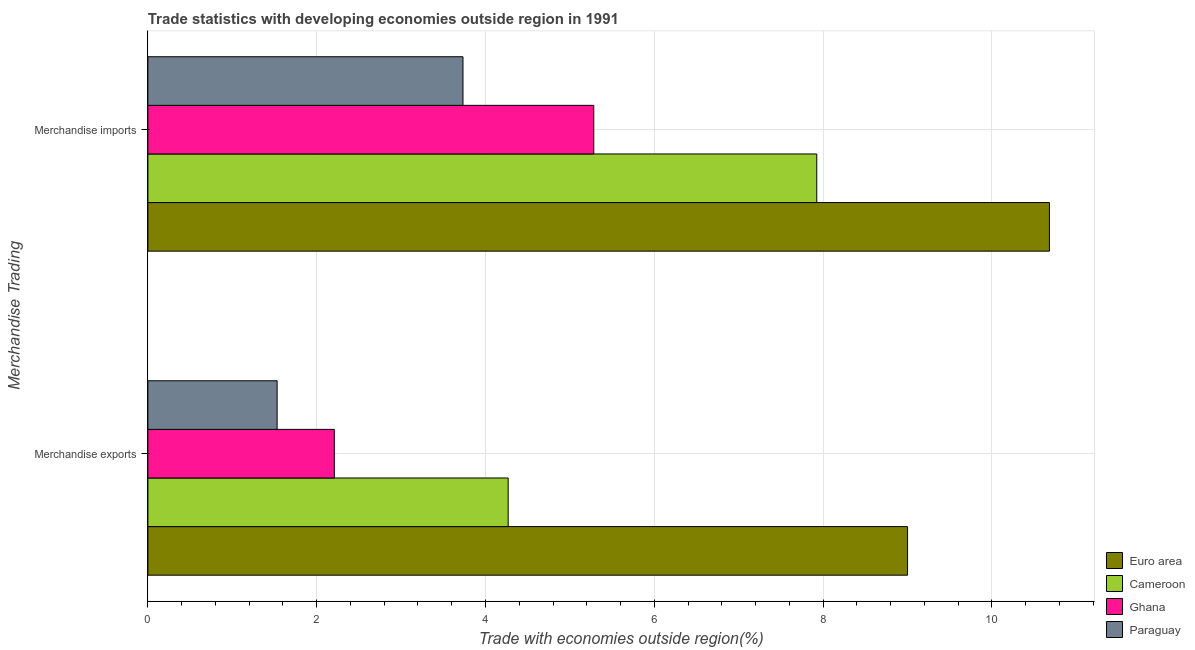How many different coloured bars are there?
Your response must be concise. 4. Are the number of bars on each tick of the Y-axis equal?
Keep it short and to the point. Yes. How many bars are there on the 2nd tick from the bottom?
Provide a succinct answer. 4. What is the merchandise exports in Ghana?
Offer a very short reply. 2.21. Across all countries, what is the maximum merchandise imports?
Ensure brevity in your answer.  10.68. Across all countries, what is the minimum merchandise imports?
Your answer should be compact. 3.73. In which country was the merchandise exports maximum?
Offer a terse response. Euro area. In which country was the merchandise exports minimum?
Provide a short and direct response. Paraguay. What is the total merchandise exports in the graph?
Make the answer very short. 17.01. What is the difference between the merchandise imports in Euro area and that in Paraguay?
Offer a terse response. 6.95. What is the difference between the merchandise exports in Euro area and the merchandise imports in Paraguay?
Keep it short and to the point. 5.27. What is the average merchandise exports per country?
Provide a succinct answer. 4.25. What is the difference between the merchandise exports and merchandise imports in Ghana?
Offer a terse response. -3.07. In how many countries, is the merchandise imports greater than 4 %?
Keep it short and to the point. 3. What is the ratio of the merchandise imports in Paraguay to that in Ghana?
Offer a very short reply. 0.71. What does the 3rd bar from the top in Merchandise exports represents?
Provide a short and direct response. Cameroon. Are all the bars in the graph horizontal?
Make the answer very short. Yes. How many countries are there in the graph?
Your answer should be very brief. 4. What is the difference between two consecutive major ticks on the X-axis?
Your answer should be very brief. 2. Are the values on the major ticks of X-axis written in scientific E-notation?
Offer a terse response. No. Does the graph contain any zero values?
Offer a terse response. No. Where does the legend appear in the graph?
Ensure brevity in your answer.  Bottom right. How many legend labels are there?
Give a very brief answer. 4. What is the title of the graph?
Offer a very short reply. Trade statistics with developing economies outside region in 1991. What is the label or title of the X-axis?
Offer a terse response. Trade with economies outside region(%). What is the label or title of the Y-axis?
Make the answer very short. Merchandise Trading. What is the Trade with economies outside region(%) in Euro area in Merchandise exports?
Offer a very short reply. 9. What is the Trade with economies outside region(%) of Cameroon in Merchandise exports?
Provide a succinct answer. 4.27. What is the Trade with economies outside region(%) of Ghana in Merchandise exports?
Your response must be concise. 2.21. What is the Trade with economies outside region(%) of Paraguay in Merchandise exports?
Keep it short and to the point. 1.53. What is the Trade with economies outside region(%) in Euro area in Merchandise imports?
Keep it short and to the point. 10.68. What is the Trade with economies outside region(%) in Cameroon in Merchandise imports?
Keep it short and to the point. 7.92. What is the Trade with economies outside region(%) in Ghana in Merchandise imports?
Your response must be concise. 5.28. What is the Trade with economies outside region(%) in Paraguay in Merchandise imports?
Offer a very short reply. 3.73. Across all Merchandise Trading, what is the maximum Trade with economies outside region(%) in Euro area?
Your answer should be very brief. 10.68. Across all Merchandise Trading, what is the maximum Trade with economies outside region(%) in Cameroon?
Your answer should be very brief. 7.92. Across all Merchandise Trading, what is the maximum Trade with economies outside region(%) of Ghana?
Your answer should be very brief. 5.28. Across all Merchandise Trading, what is the maximum Trade with economies outside region(%) in Paraguay?
Give a very brief answer. 3.73. Across all Merchandise Trading, what is the minimum Trade with economies outside region(%) of Euro area?
Your response must be concise. 9. Across all Merchandise Trading, what is the minimum Trade with economies outside region(%) in Cameroon?
Offer a terse response. 4.27. Across all Merchandise Trading, what is the minimum Trade with economies outside region(%) of Ghana?
Offer a very short reply. 2.21. Across all Merchandise Trading, what is the minimum Trade with economies outside region(%) in Paraguay?
Ensure brevity in your answer.  1.53. What is the total Trade with economies outside region(%) of Euro area in the graph?
Ensure brevity in your answer.  19.68. What is the total Trade with economies outside region(%) in Cameroon in the graph?
Give a very brief answer. 12.19. What is the total Trade with economies outside region(%) of Ghana in the graph?
Your response must be concise. 7.49. What is the total Trade with economies outside region(%) of Paraguay in the graph?
Your response must be concise. 5.26. What is the difference between the Trade with economies outside region(%) of Euro area in Merchandise exports and that in Merchandise imports?
Make the answer very short. -1.68. What is the difference between the Trade with economies outside region(%) in Cameroon in Merchandise exports and that in Merchandise imports?
Offer a terse response. -3.66. What is the difference between the Trade with economies outside region(%) in Ghana in Merchandise exports and that in Merchandise imports?
Offer a very short reply. -3.07. What is the difference between the Trade with economies outside region(%) in Paraguay in Merchandise exports and that in Merchandise imports?
Offer a very short reply. -2.2. What is the difference between the Trade with economies outside region(%) in Euro area in Merchandise exports and the Trade with economies outside region(%) in Cameroon in Merchandise imports?
Your answer should be very brief. 1.08. What is the difference between the Trade with economies outside region(%) in Euro area in Merchandise exports and the Trade with economies outside region(%) in Ghana in Merchandise imports?
Ensure brevity in your answer.  3.72. What is the difference between the Trade with economies outside region(%) in Euro area in Merchandise exports and the Trade with economies outside region(%) in Paraguay in Merchandise imports?
Keep it short and to the point. 5.27. What is the difference between the Trade with economies outside region(%) of Cameroon in Merchandise exports and the Trade with economies outside region(%) of Ghana in Merchandise imports?
Your answer should be compact. -1.01. What is the difference between the Trade with economies outside region(%) of Cameroon in Merchandise exports and the Trade with economies outside region(%) of Paraguay in Merchandise imports?
Give a very brief answer. 0.54. What is the difference between the Trade with economies outside region(%) of Ghana in Merchandise exports and the Trade with economies outside region(%) of Paraguay in Merchandise imports?
Offer a very short reply. -1.52. What is the average Trade with economies outside region(%) of Euro area per Merchandise Trading?
Offer a very short reply. 9.84. What is the average Trade with economies outside region(%) of Cameroon per Merchandise Trading?
Provide a short and direct response. 6.1. What is the average Trade with economies outside region(%) of Ghana per Merchandise Trading?
Provide a succinct answer. 3.75. What is the average Trade with economies outside region(%) of Paraguay per Merchandise Trading?
Your answer should be very brief. 2.63. What is the difference between the Trade with economies outside region(%) in Euro area and Trade with economies outside region(%) in Cameroon in Merchandise exports?
Offer a terse response. 4.73. What is the difference between the Trade with economies outside region(%) in Euro area and Trade with economies outside region(%) in Ghana in Merchandise exports?
Keep it short and to the point. 6.79. What is the difference between the Trade with economies outside region(%) in Euro area and Trade with economies outside region(%) in Paraguay in Merchandise exports?
Keep it short and to the point. 7.47. What is the difference between the Trade with economies outside region(%) in Cameroon and Trade with economies outside region(%) in Ghana in Merchandise exports?
Your answer should be compact. 2.06. What is the difference between the Trade with economies outside region(%) in Cameroon and Trade with economies outside region(%) in Paraguay in Merchandise exports?
Provide a succinct answer. 2.74. What is the difference between the Trade with economies outside region(%) of Ghana and Trade with economies outside region(%) of Paraguay in Merchandise exports?
Offer a terse response. 0.68. What is the difference between the Trade with economies outside region(%) in Euro area and Trade with economies outside region(%) in Cameroon in Merchandise imports?
Your response must be concise. 2.76. What is the difference between the Trade with economies outside region(%) in Euro area and Trade with economies outside region(%) in Ghana in Merchandise imports?
Your answer should be very brief. 5.4. What is the difference between the Trade with economies outside region(%) in Euro area and Trade with economies outside region(%) in Paraguay in Merchandise imports?
Keep it short and to the point. 6.95. What is the difference between the Trade with economies outside region(%) of Cameroon and Trade with economies outside region(%) of Ghana in Merchandise imports?
Ensure brevity in your answer.  2.64. What is the difference between the Trade with economies outside region(%) in Cameroon and Trade with economies outside region(%) in Paraguay in Merchandise imports?
Your response must be concise. 4.19. What is the difference between the Trade with economies outside region(%) of Ghana and Trade with economies outside region(%) of Paraguay in Merchandise imports?
Ensure brevity in your answer.  1.55. What is the ratio of the Trade with economies outside region(%) of Euro area in Merchandise exports to that in Merchandise imports?
Make the answer very short. 0.84. What is the ratio of the Trade with economies outside region(%) in Cameroon in Merchandise exports to that in Merchandise imports?
Your answer should be compact. 0.54. What is the ratio of the Trade with economies outside region(%) of Ghana in Merchandise exports to that in Merchandise imports?
Your answer should be very brief. 0.42. What is the ratio of the Trade with economies outside region(%) in Paraguay in Merchandise exports to that in Merchandise imports?
Make the answer very short. 0.41. What is the difference between the highest and the second highest Trade with economies outside region(%) of Euro area?
Keep it short and to the point. 1.68. What is the difference between the highest and the second highest Trade with economies outside region(%) in Cameroon?
Make the answer very short. 3.66. What is the difference between the highest and the second highest Trade with economies outside region(%) in Ghana?
Ensure brevity in your answer.  3.07. What is the difference between the highest and the second highest Trade with economies outside region(%) of Paraguay?
Keep it short and to the point. 2.2. What is the difference between the highest and the lowest Trade with economies outside region(%) of Euro area?
Your answer should be very brief. 1.68. What is the difference between the highest and the lowest Trade with economies outside region(%) of Cameroon?
Ensure brevity in your answer.  3.66. What is the difference between the highest and the lowest Trade with economies outside region(%) of Ghana?
Offer a very short reply. 3.07. What is the difference between the highest and the lowest Trade with economies outside region(%) in Paraguay?
Offer a terse response. 2.2. 